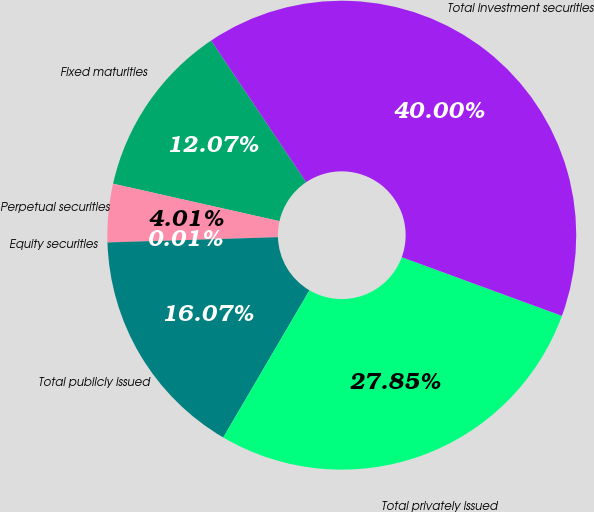Convert chart to OTSL. <chart><loc_0><loc_0><loc_500><loc_500><pie_chart><fcel>Fixed maturities<fcel>Perpetual securities<fcel>Equity securities<fcel>Total publicly issued<fcel>Total privately issued<fcel>Total investment securities<nl><fcel>12.07%<fcel>4.01%<fcel>0.01%<fcel>16.07%<fcel>27.85%<fcel>40.0%<nl></chart> 